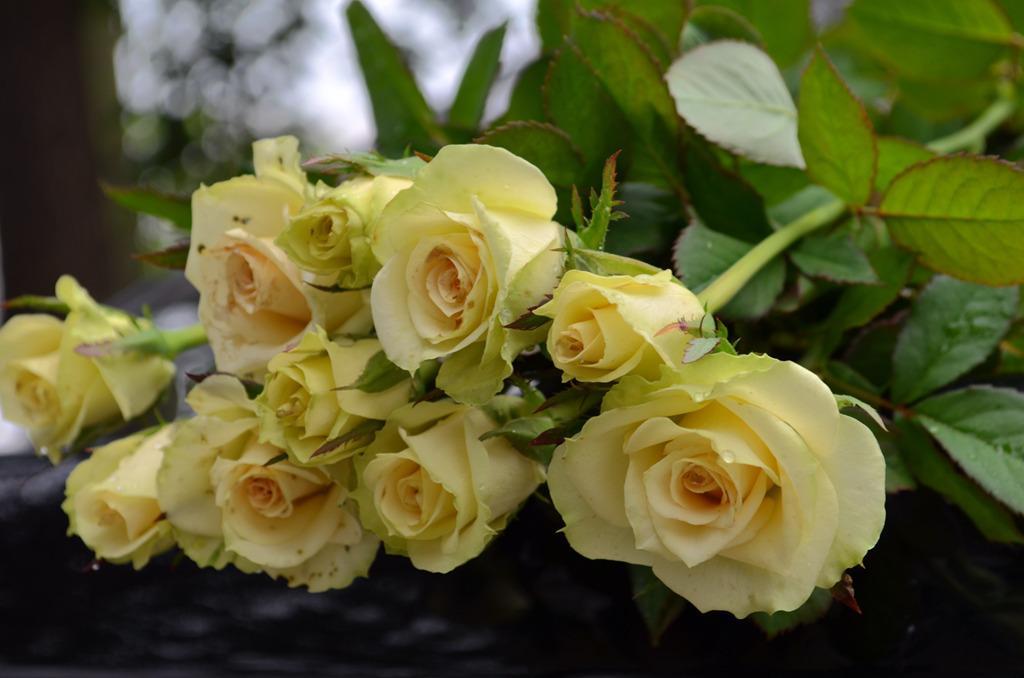Please provide a concise description of this image. This picture seems to be clicked outside. In the foreground we can see the roses and the green leaves. The background of the image is blurry. 